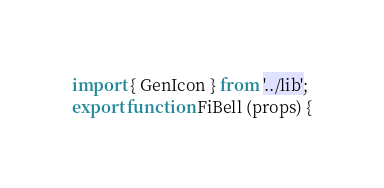Convert code to text. <code><loc_0><loc_0><loc_500><loc_500><_JavaScript_>import { GenIcon } from '../lib';
export function FiBell (props) {</code> 